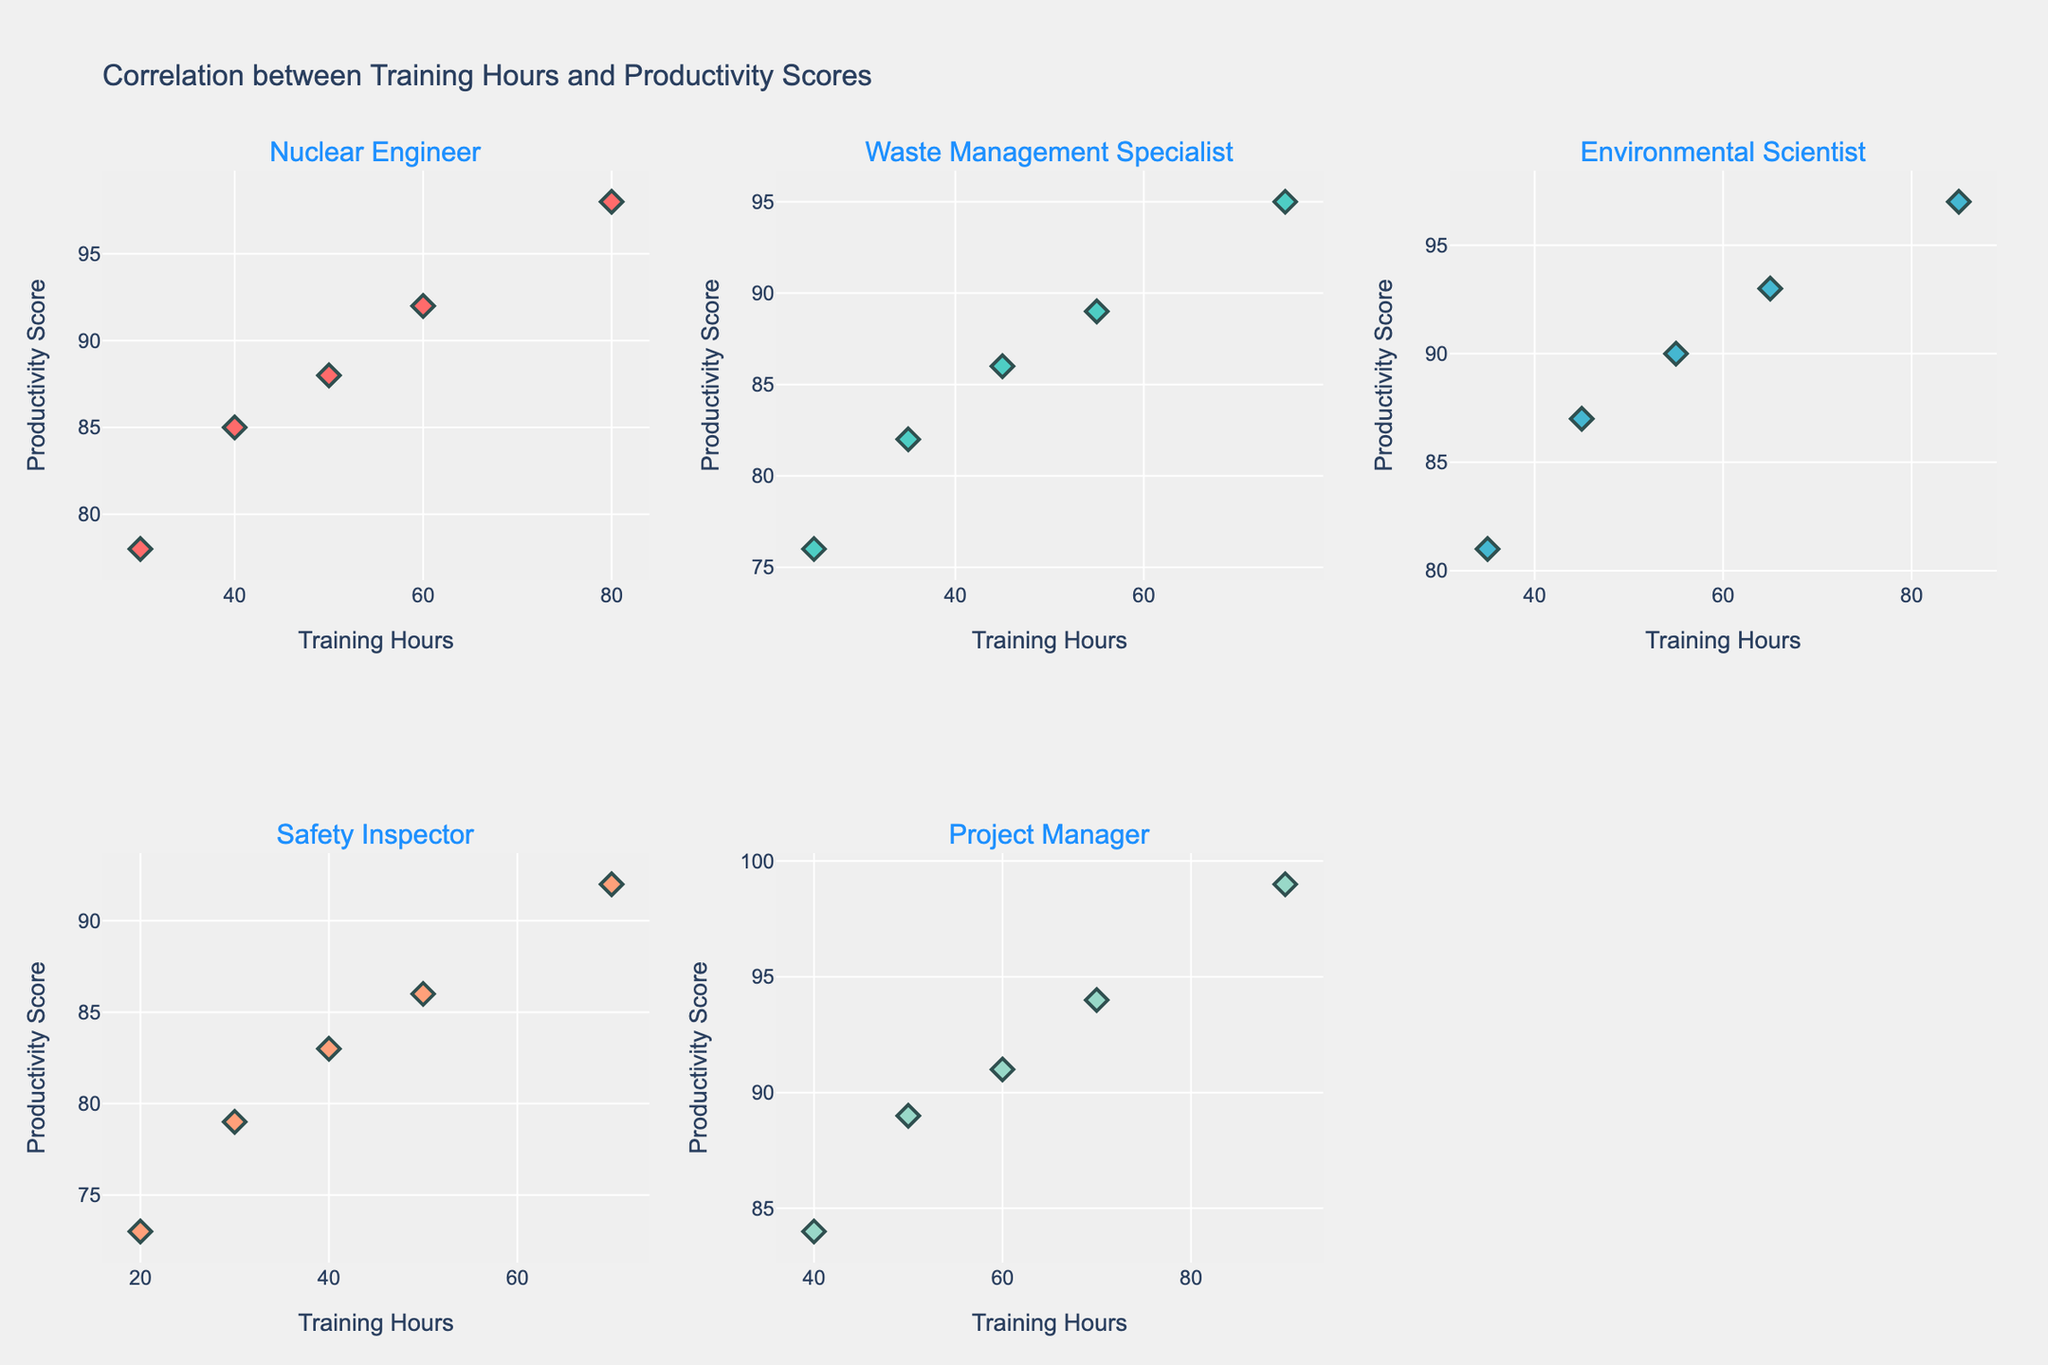What is the title of the figure? The title of the figure is usually located at the top. The title is "Correlation between Training Hours and Productivity Scores."
Answer: Correlation between Training Hours and Productivity Scores Which job category has the highest productivity score for 90 training hours? By examining the scatter plot for each job category, the Project Manager category has a productivity score of 99 for 90 training hours.
Answer: Project Manager How many job categories are represented in the figure? The subplot titles indicate the number of job categories. There are five job categories: Nuclear Engineer, Waste Management Specialist, Environmental Scientist, Safety Inspector, and Project Manager.
Answer: 5 Which job category appears to have the most data points? By comparing the number of markers in each subplot, all job categories appear to have an equal number of data points, specifically 5.
Answer: All have equal data points What is the productivity score for Nuclear Engineers at 40 training hours? Looking at the subplot for Nuclear Engineers, the data point at 40 training hours corresponds to a productivity score of 85.
Answer: 85 Which job category has the steepest increase in productivity score as training hours increase? By comparing the slopes of the data points' trend in each subplot, the Project Manager category shows the steepest increase.
Answer: Project Manager What is the average productivity score for Environmental Scientists for training hours of 45, 65, and 85? Sum the productivity scores (87, 93, 97) and divide by the number of data points (3). (87 + 93 + 97) / 3 = 277 / 3 = 92.33
Answer: 92.33 Compare the productivity scores of Waste Management Specialists at 35 and 45 training hours. Which is higher? By examining the subplot for Waste Management Specialists, 35 training hours corresponds to a score of 82, and 45 training hours corresponds to a score of 86. The latter is higher.
Answer: 45 training hours What visual marker is used to represent data points? By observing the markers in the plots, each data point is represented by a diamond shape symbol with a dark outline.
Answer: Diamond shape What is the range of productivity scores for Safety Inspectors? The productivity scores for Safety Inspectors range from the lowest point at 73 to the highest at 92.
Answer: 73 to 92 